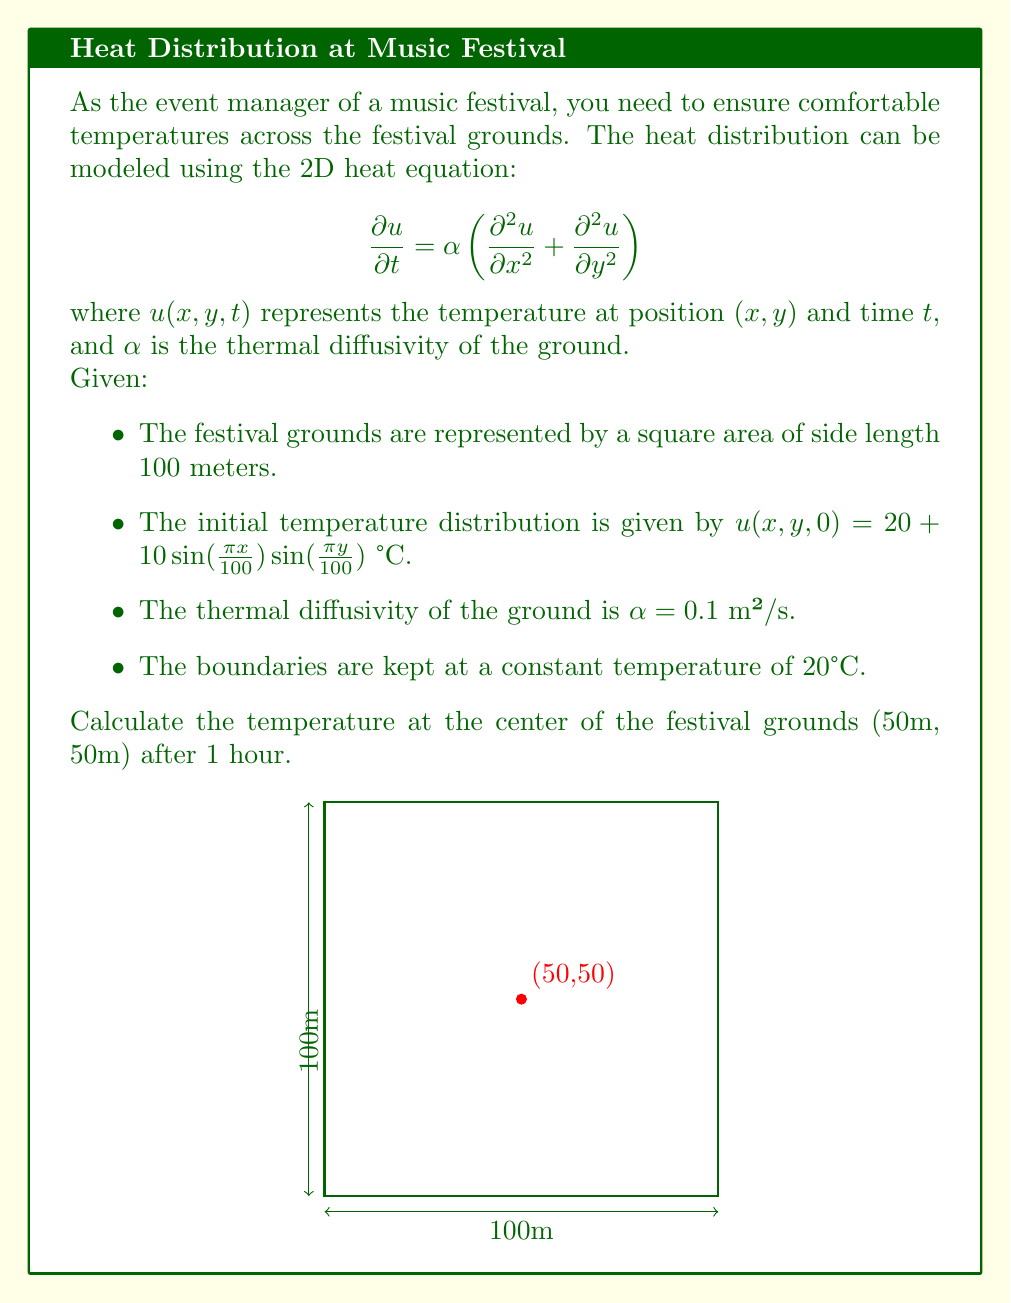Solve this math problem. To solve this problem, we need to use the method of separation of variables for the 2D heat equation.

Step 1: Separate the variables
Let $u(x,y,t) = X(x)Y(y)T(t)$

Step 2: Substitute into the heat equation
$$X(x)Y(y)T'(t) = \alpha[X''(x)Y(y)T(t) + X(x)Y''(y)T(t)]$$

Step 3: Divide by $XYT$
$$\frac{T'(t)}{T(t)} = \alpha\left[\frac{X''(x)}{X(x)} + \frac{Y''(y)}{Y(y)}\right] = -\lambda^2$$

Step 4: Solve the resulting ODEs
$$T(t) = e^{-\alpha\lambda^2 t}$$
$$X(x) = A\sin(\lambda x) + B\cos(\lambda x)$$
$$Y(y) = C\sin(\mu y) + D\cos(\mu y)$$

where $\lambda^2 + \mu^2 = \frac{\lambda^2}{\alpha}$

Step 5: Apply boundary conditions
The boundary conditions imply that $\lambda = \frac{n\pi}{100}$ and $\mu = \frac{m\pi}{100}$ where $n$ and $m$ are integers.

Step 6: Write the general solution
$$u(x,y,t) = \sum_{n=1}^{\infty}\sum_{m=1}^{\infty} A_{nm}\sin(\frac{n\pi x}{100})\sin(\frac{m\pi y}{100})e^{-\alpha(\frac{n^2\pi^2}{10000}+\frac{m^2\pi^2}{10000})t}$$

Step 7: Apply initial condition
The initial condition matches our solution when $n=m=1$ and $A_{11} = 10$. All other $A_{nm} = 0$.

Step 8: Final solution
$$u(x,y,t) = 20 + 10\sin(\frac{\pi x}{100})\sin(\frac{\pi y}{100})e^{-\alpha(\frac{2\pi^2}{10000})t}$$

Step 9: Calculate the temperature at (50,50) after 1 hour
$$u(50,50,3600) = 20 + 10\sin(\frac{\pi}{2})\sin(\frac{\pi}{2})e^{-0.1(\frac{2\pi^2}{10000})(3600)}$$
$$= 20 + 10e^{-0.1(\frac{2\pi^2}{10000})(3600)} \approx 20.0073$$
Answer: 20.0073°C 